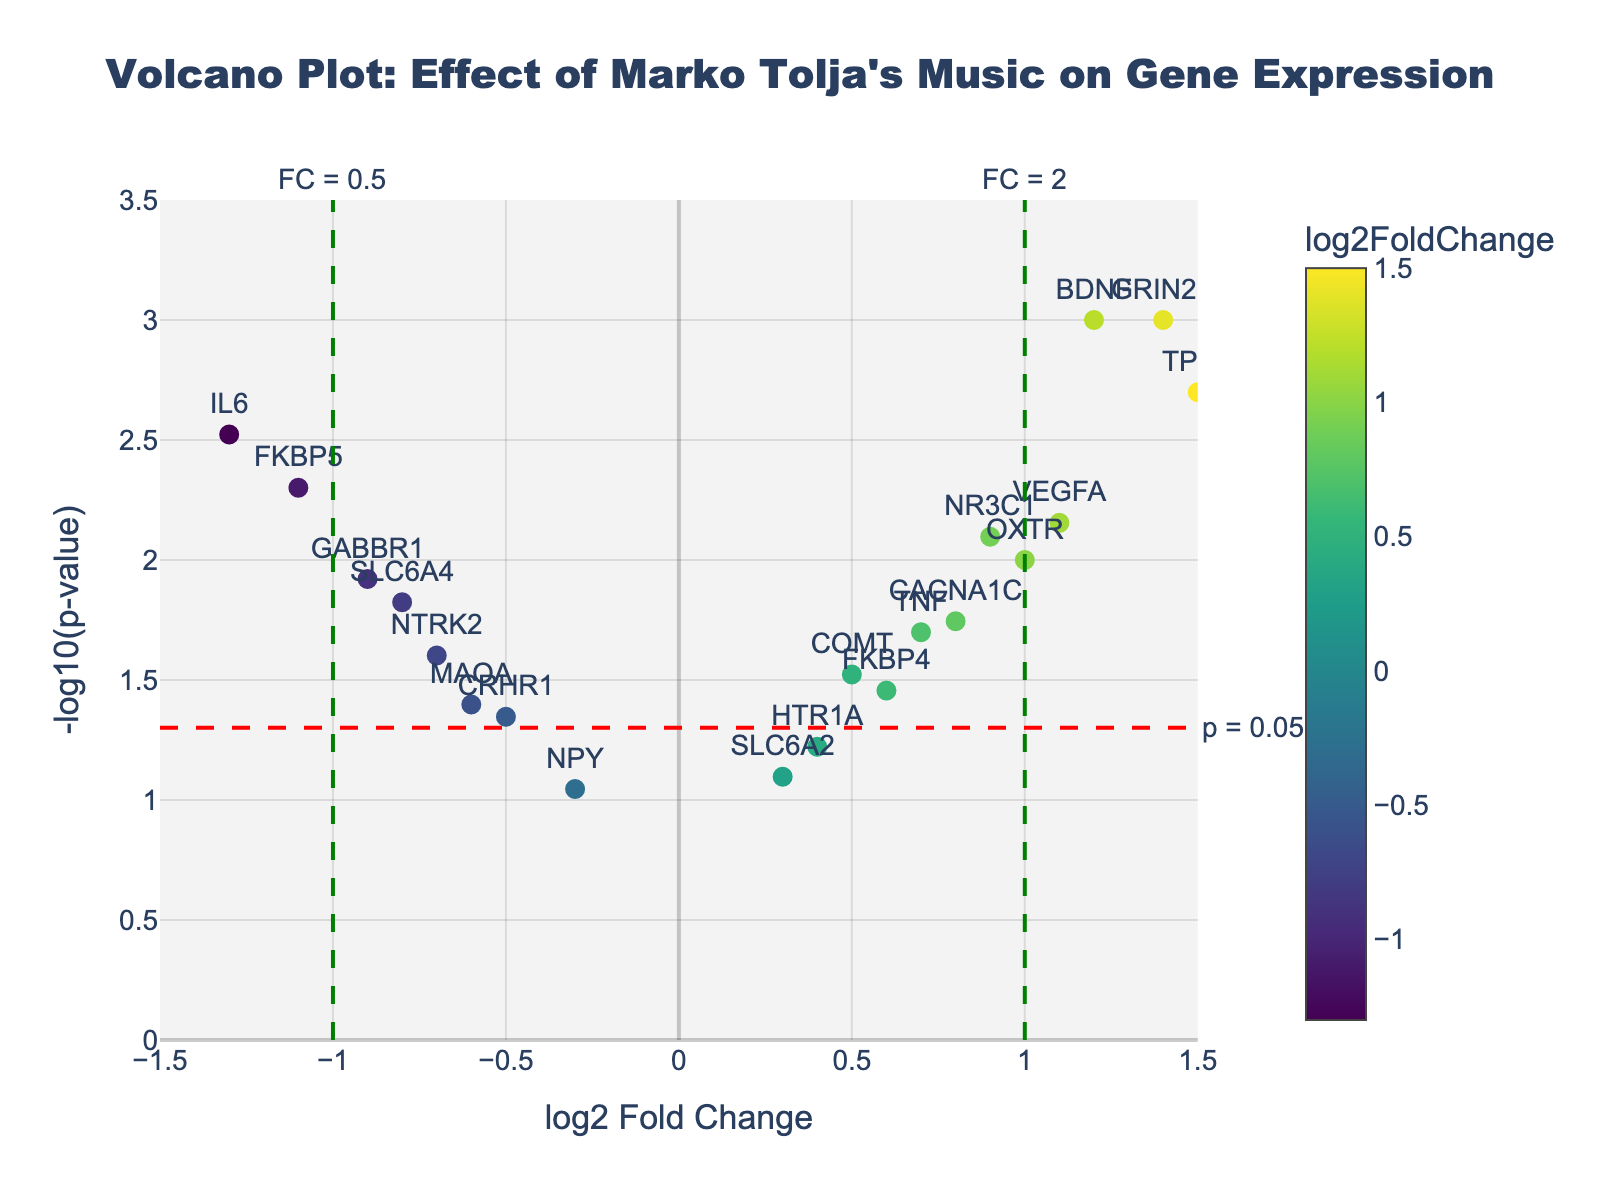What's the title of the figure? The title is usually positioned at the top of the figure. Here, it's a descriptive overview of what the plot represents.
Answer: "Volcano Plot: Effect of Marko Tolja's Music on Gene Expression" How many genes have a p-value less than 0.05? Look for data points above the red dashed line at -log10(p-value) of 1.3, which marks a p-value of 0.05.
Answer: 15 Which gene shows the highest log2 fold change? Identify the gene that is positioned furthest along the x-axis in either direction.
Answer: TPH2 Which gene has the most statistically significant effect? The gene with the lowest p-value will have the highest -log10(p-value), appearing highest on the y-axis.
Answer: BDNF or GRIN2B Are there any genes with a log2 fold change between -0.5 and 0.5? Check the x-axis for data points between -0.5 and 0.5.
Answer: HTR1A, NPY, SLC6A2 Which gene has the lowest log2 fold change? Identify the gene that is positioned furthest left on the x-axis.
Answer: IL6 How many genes have a log2 fold change greater than 1? Count the number of points to the right of the green dashed line at x=1.
Answer: 4 Which gene is the closest to the significance threshold of p = 0.05? Find the gene closest to the red dashed line at -log10(p-value) of 1.3.
Answer: CRHR1 What is the log2 fold change value for the gene VEGFA? Locate VEGFA in the plot and read its position on the x-axis.
Answer: 1.1 Compare the fold change of BDNF and FKBP5. Which one has a greater effect? Compare their positions on the x-axis.
Answer: BDNF 